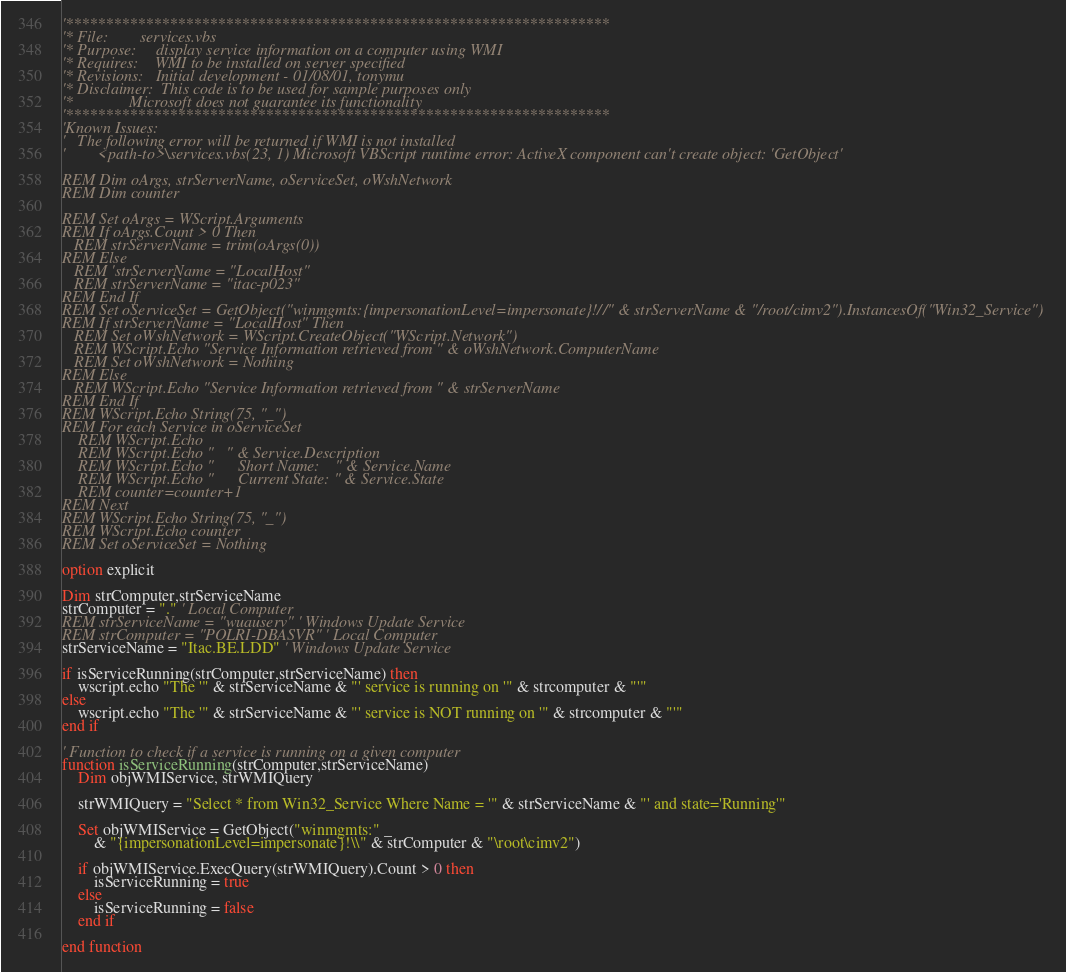<code> <loc_0><loc_0><loc_500><loc_500><_VisualBasic_>'********************************************************************
'* File:        services.vbs
'* Purpose:     display service information on a computer using WMI 
'* Requires:    WMI to be installed on server specified
'* Revisions:   Initial development - 01/08/01, tonymu
'* Disclaimer:  This code is to be used for sample purposes only
'*              Microsoft does not guarantee its functionality
'********************************************************************
'Known Issues:
'   The following error will be returned if WMI is not installed
'        <path-to>\services.vbs(23, 1) Microsoft VBScript runtime error: ActiveX component can't create object: 'GetObject'

REM Dim oArgs, strServerName, oServiceSet, oWshNetwork
REM Dim counter

REM Set oArgs = WScript.Arguments
REM If oArgs.Count > 0 Then
   REM strServerName = trim(oArgs(0))
REM Else
   REM 'strServerName = "LocalHost"
   REM strServerName = "itac-p023"
REM End If
REM Set oServiceSet = GetObject("winmgmts:{impersonationLevel=impersonate}!//" & strServerName & "/root/cimv2").InstancesOf("Win32_Service")
REM If strServerName = "LocalHost" Then
   REM Set oWshNetwork = WScript.CreateObject("WScript.Network")
   REM WScript.Echo "Service Information retrieved from " & oWshNetwork.ComputerName
   REM Set oWshNetwork = Nothing
REM Else
   REM WScript.Echo "Service Information retrieved from " & strServerName
REM End If
REM WScript.Echo String(75, "_")
REM For each Service in oServiceSet
	REM WScript.Echo
	REM WScript.Echo "   " & Service.Description
	REM WScript.Echo "      Short Name:    " & Service.Name 
	REM WScript.Echo "      Current State: " & Service.State
	REM counter=counter+1
REM Next
REM WScript.Echo String(75, "_")
REM WScript.Echo counter
REM Set oServiceSet = Nothing

option explicit

Dim strComputer,strServiceName
strComputer = "." ' Local Computer
REM strServiceName = "wuauserv" ' Windows Update Service
REM strComputer = "POLRI-DBASVR" ' Local Computer
strServiceName = "Itac.BE.LDD" ' Windows Update Service

if isServiceRunning(strComputer,strServiceName) then
	wscript.echo "The '" & strServiceName & "' service is running on '" & strcomputer & "'"
else
	wscript.echo "The '" & strServiceName & "' service is NOT running on '" & strcomputer & "'"
end if

' Function to check if a service is running on a given computer
function isServiceRunning(strComputer,strServiceName)
	Dim objWMIService, strWMIQuery

	strWMIQuery = "Select * from Win32_Service Where Name = '" & strServiceName & "' and state='Running'"

	Set objWMIService = GetObject("winmgmts:" _
		& "{impersonationLevel=impersonate}!\\" & strComputer & "\root\cimv2")

	if objWMIService.ExecQuery(strWMIQuery).Count > 0 then
		isServiceRunning = true
	else
		isServiceRunning = false
	end if

end function</code> 